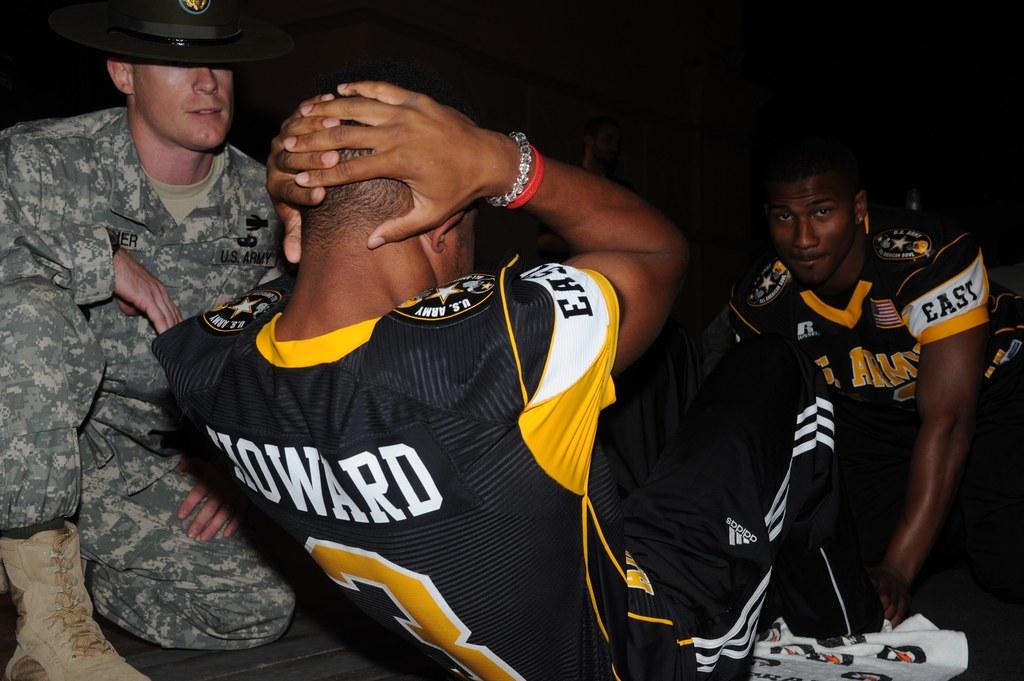What name is on the back of the jersey?
Your response must be concise. Howard. What number does howard wear?
Your answer should be very brief. 3. 